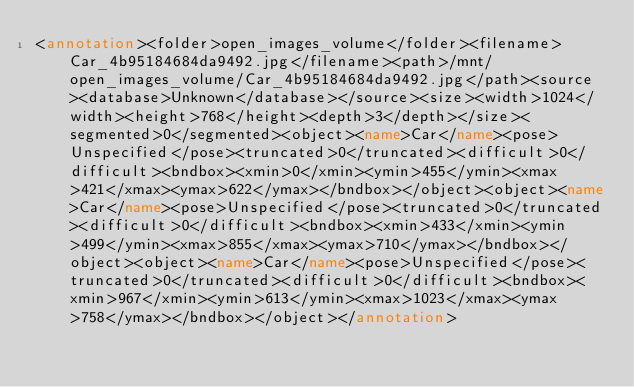<code> <loc_0><loc_0><loc_500><loc_500><_XML_><annotation><folder>open_images_volume</folder><filename>Car_4b95184684da9492.jpg</filename><path>/mnt/open_images_volume/Car_4b95184684da9492.jpg</path><source><database>Unknown</database></source><size><width>1024</width><height>768</height><depth>3</depth></size><segmented>0</segmented><object><name>Car</name><pose>Unspecified</pose><truncated>0</truncated><difficult>0</difficult><bndbox><xmin>0</xmin><ymin>455</ymin><xmax>421</xmax><ymax>622</ymax></bndbox></object><object><name>Car</name><pose>Unspecified</pose><truncated>0</truncated><difficult>0</difficult><bndbox><xmin>433</xmin><ymin>499</ymin><xmax>855</xmax><ymax>710</ymax></bndbox></object><object><name>Car</name><pose>Unspecified</pose><truncated>0</truncated><difficult>0</difficult><bndbox><xmin>967</xmin><ymin>613</ymin><xmax>1023</xmax><ymax>758</ymax></bndbox></object></annotation></code> 